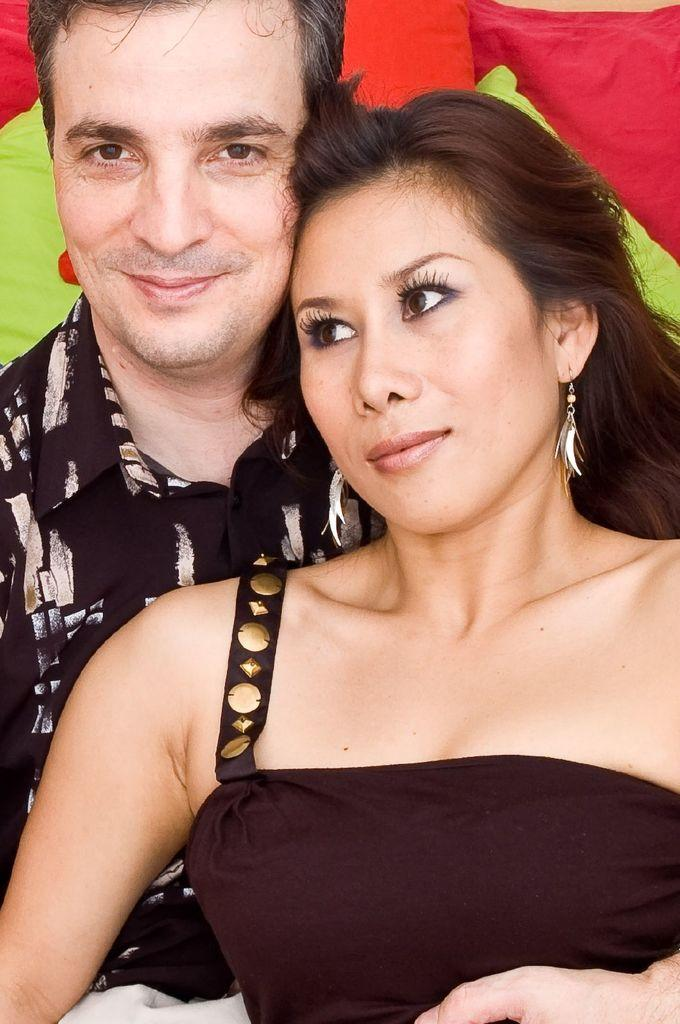How many people are in the image? There are two persons in the image. What can be seen behind the two persons? There are colorful objects visible behind the two persons. What type of berry is being used as a reason for digestion in the image? There is no berry or reference to digestion in the image; it only features two persons and colorful objects in the background. 